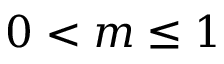Convert formula to latex. <formula><loc_0><loc_0><loc_500><loc_500>0 < m \leq 1</formula> 